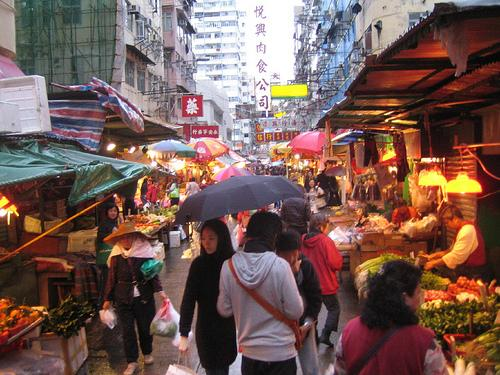What is the occupation of the man in the red vest? vendor 